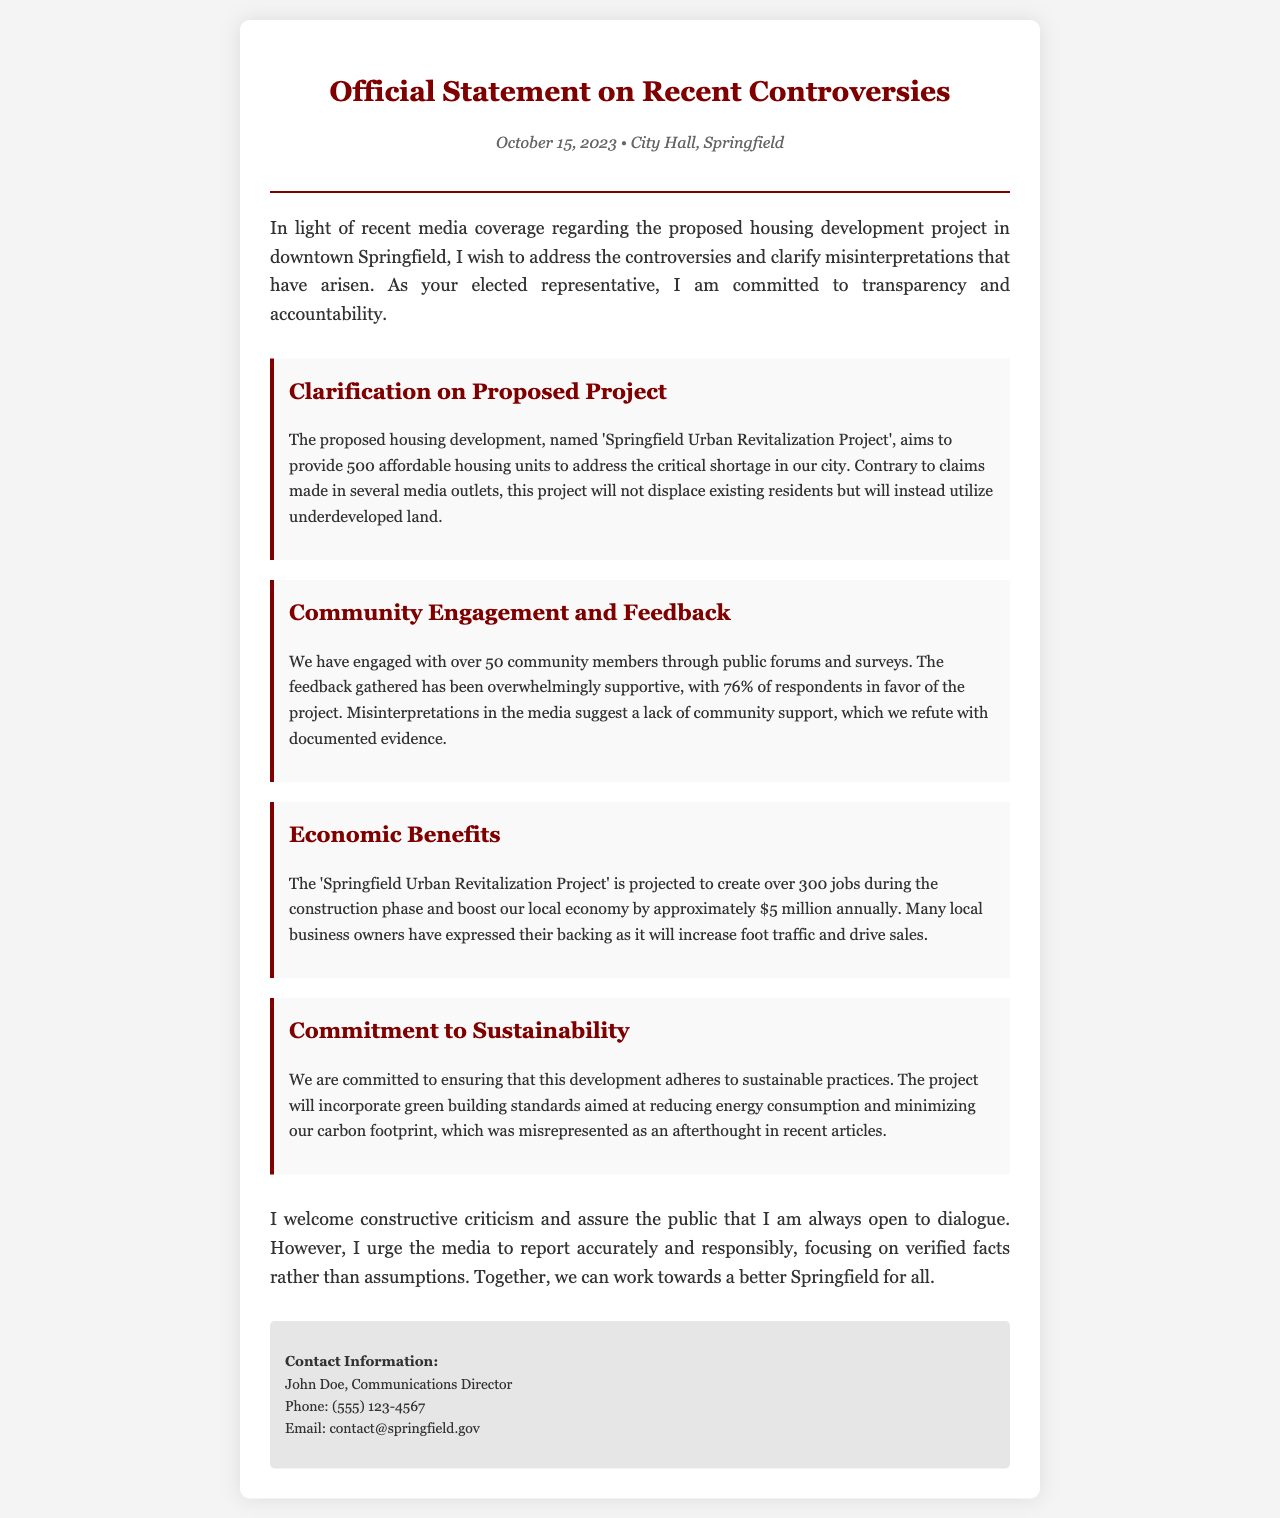What is the name of the proposed housing project? The name of the proposed housing project is mentioned in the document, which is 'Springfield Urban Revitalization Project'.
Answer: Springfield Urban Revitalization Project How many affordable housing units will be provided? The document states that the proposed project aims to provide 500 affordable housing units.
Answer: 500 What percentage of community respondents were in favor of the project? According to the document, 76% of respondents supported the project, which indicates high community support.
Answer: 76% How many jobs is the project projected to create during construction? The document specifies that the project is projected to create over 300 jobs during the construction phase.
Answer: 300 What is the estimated economic boost to the local economy annually? The document provides a figure estimating that the local economy will be boosted by approximately $5 million annually.
Answer: $5 million What commitment to environmental practices does the project include? The document mentions a commitment to sustainable practices and incorporates green building standards to reduce energy consumption.
Answer: Sustainable practices Who is the Communications Director? John Doe is identified as the Communications Director in the contact information section of the document.
Answer: John Doe On what date was this official statement released? The date of the official statement is clearly stated as October 15, 2023.
Answer: October 15, 2023 What is the address mentioned in the document? The document states the location of the press release was at City Hall, Springfield.
Answer: City Hall, Springfield 